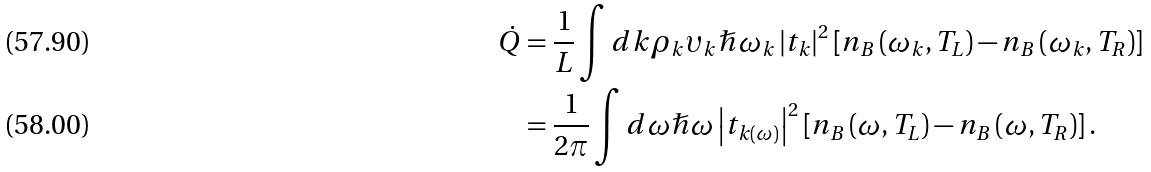Convert formula to latex. <formula><loc_0><loc_0><loc_500><loc_500>\dot { Q } & = \frac { 1 } { L } \int d k \rho _ { k } \upsilon _ { k } \hslash \omega _ { k } \left | t _ { k } \right | ^ { 2 } \left [ n _ { B } \left ( \omega _ { k } , T _ { L } \right ) - n _ { B } \left ( \omega _ { k } , T _ { R } \right ) \right ] \\ & = \frac { 1 } { 2 \pi } \int d \omega \hslash \omega \left | t _ { k \left ( \omega \right ) } \right | ^ { 2 } \left [ n _ { B } \left ( \omega , T _ { L } \right ) - n _ { B } \left ( \omega , T _ { R } \right ) \right ] .</formula> 